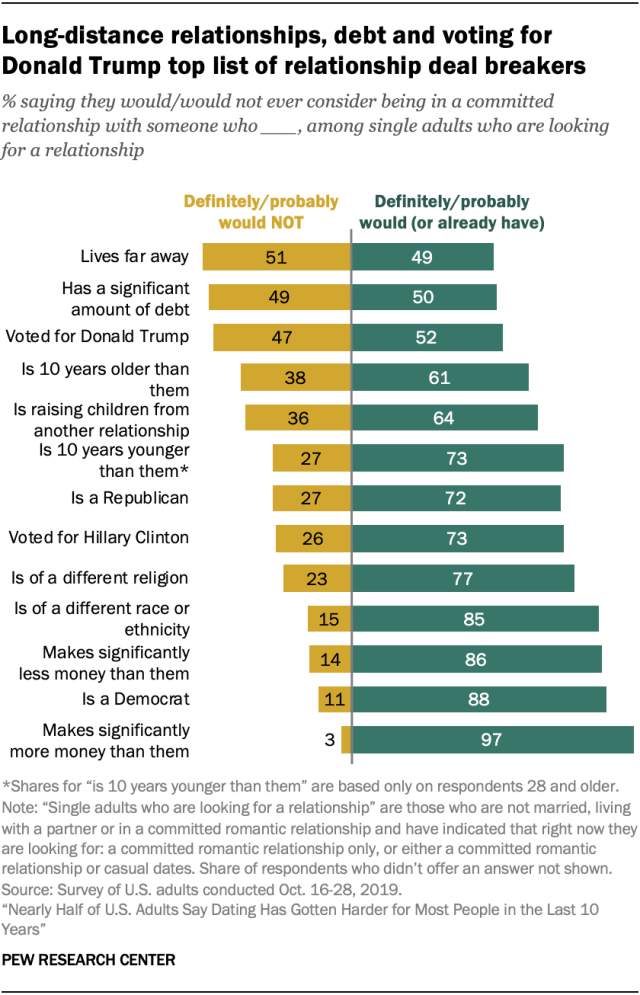Give some essential details in this illustration. The yellow bar represents the value for the "Lives far away" category, and the value is 51. The value of the yellow bar is decreasing and the value of the blue bar is increasing from top to bottom. 